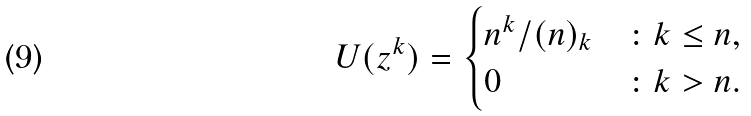<formula> <loc_0><loc_0><loc_500><loc_500>U ( z ^ { k } ) = \begin{cases} n ^ { k } / ( n ) _ { k } & \colon k \leq n , \\ 0 & \colon k > n . \end{cases}</formula> 